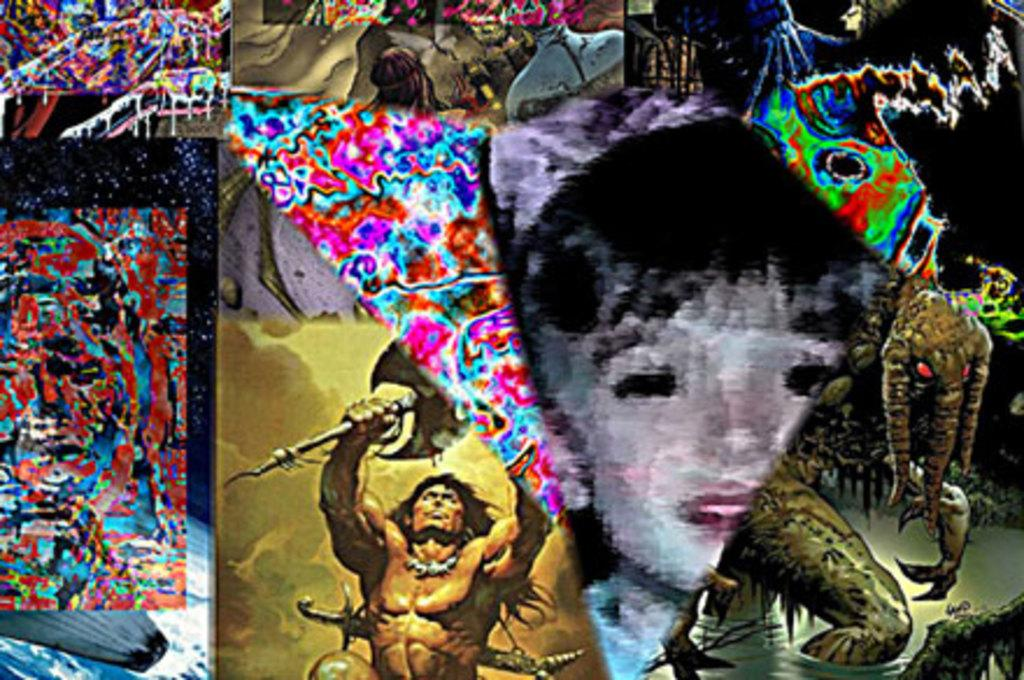What is the main subject of the image? The main subject of the image is a painting. What types of subjects are depicted in the painting? The painting contains persons and animals. What type of hill can be seen in the painting? There is no hill present in the painting; it contains only persons and animals. How does the painting depict the act of saying good-bye? The painting does not depict any act, including good-bye. 